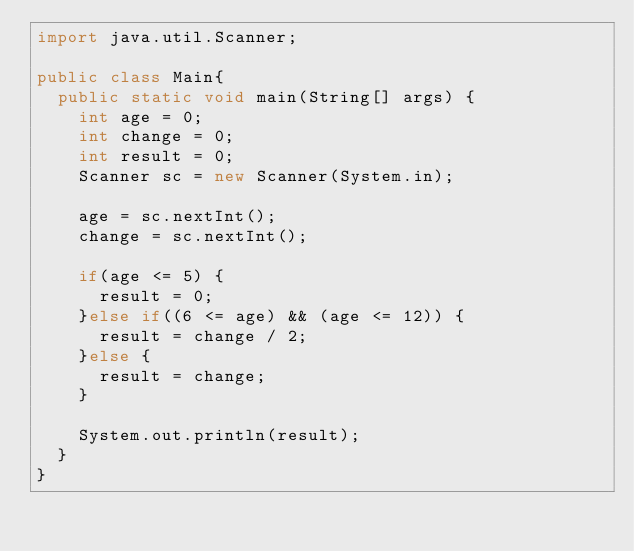<code> <loc_0><loc_0><loc_500><loc_500><_Java_>import java.util.Scanner;

public class Main{
  public static void main(String[] args) {
    int age = 0;
    int change = 0;
    int result = 0;
    Scanner sc = new Scanner(System.in);
    
    age = sc.nextInt();
    change = sc.nextInt();
    
    if(age <= 5) {
      result = 0;
    }else if((6 <= age) && (age <= 12)) {
      result = change / 2;
    }else {
      result = change;
    }
    
    System.out.println(result);
  }
}</code> 